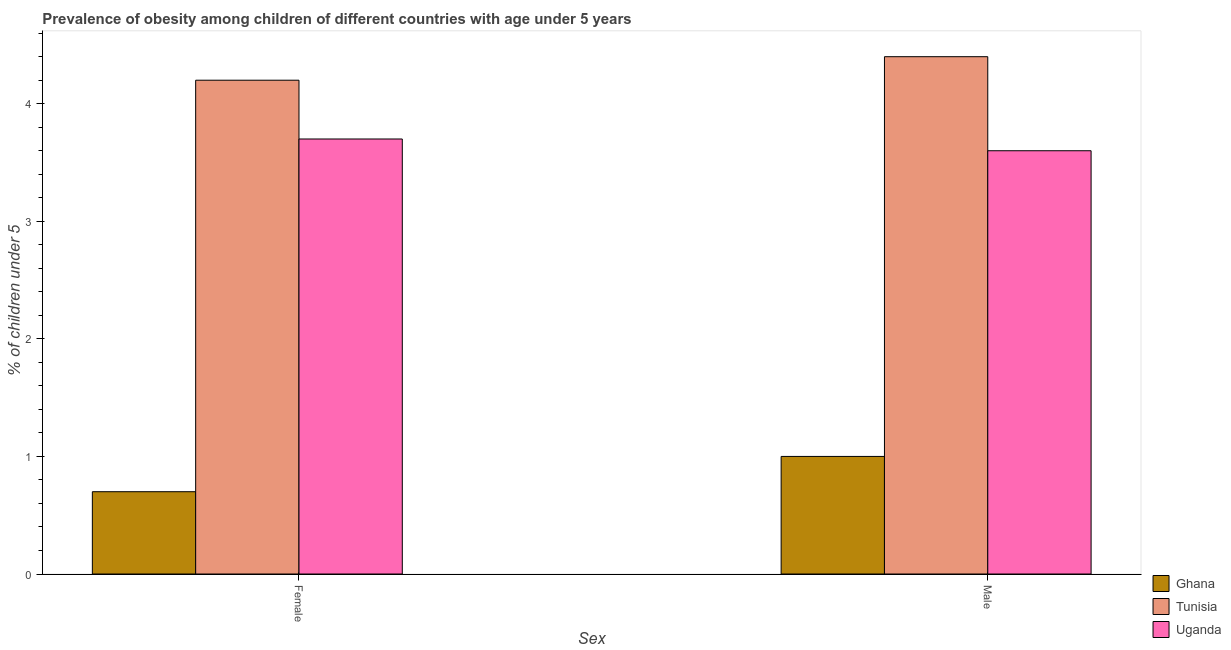How many different coloured bars are there?
Your answer should be compact. 3. How many groups of bars are there?
Your answer should be compact. 2. How many bars are there on the 1st tick from the left?
Make the answer very short. 3. What is the percentage of obese male children in Tunisia?
Make the answer very short. 4.4. Across all countries, what is the maximum percentage of obese female children?
Ensure brevity in your answer.  4.2. In which country was the percentage of obese male children maximum?
Provide a short and direct response. Tunisia. What is the total percentage of obese female children in the graph?
Give a very brief answer. 8.6. What is the difference between the percentage of obese female children in Uganda and that in Ghana?
Offer a terse response. 3. What is the difference between the percentage of obese female children in Tunisia and the percentage of obese male children in Uganda?
Give a very brief answer. 0.6. What is the difference between the percentage of obese female children and percentage of obese male children in Tunisia?
Keep it short and to the point. -0.2. What is the ratio of the percentage of obese male children in Tunisia to that in Ghana?
Provide a succinct answer. 4.4. In how many countries, is the percentage of obese male children greater than the average percentage of obese male children taken over all countries?
Offer a very short reply. 2. What does the 1st bar from the right in Male represents?
Your answer should be compact. Uganda. What is the difference between two consecutive major ticks on the Y-axis?
Your answer should be compact. 1. Are the values on the major ticks of Y-axis written in scientific E-notation?
Your answer should be very brief. No. Does the graph contain any zero values?
Your response must be concise. No. What is the title of the graph?
Your answer should be very brief. Prevalence of obesity among children of different countries with age under 5 years. What is the label or title of the X-axis?
Keep it short and to the point. Sex. What is the label or title of the Y-axis?
Ensure brevity in your answer.   % of children under 5. What is the  % of children under 5 in Ghana in Female?
Offer a terse response. 0.7. What is the  % of children under 5 in Tunisia in Female?
Provide a short and direct response. 4.2. What is the  % of children under 5 in Uganda in Female?
Your answer should be compact. 3.7. What is the  % of children under 5 of Ghana in Male?
Your answer should be very brief. 1. What is the  % of children under 5 in Tunisia in Male?
Your answer should be very brief. 4.4. What is the  % of children under 5 of Uganda in Male?
Offer a terse response. 3.6. Across all Sex, what is the maximum  % of children under 5 of Tunisia?
Your answer should be very brief. 4.4. Across all Sex, what is the maximum  % of children under 5 in Uganda?
Your answer should be very brief. 3.7. Across all Sex, what is the minimum  % of children under 5 of Ghana?
Your answer should be very brief. 0.7. Across all Sex, what is the minimum  % of children under 5 of Tunisia?
Make the answer very short. 4.2. Across all Sex, what is the minimum  % of children under 5 in Uganda?
Make the answer very short. 3.6. What is the total  % of children under 5 in Tunisia in the graph?
Your answer should be compact. 8.6. What is the difference between the  % of children under 5 of Tunisia in Female and that in Male?
Your response must be concise. -0.2. What is the difference between the  % of children under 5 of Tunisia in Female and the  % of children under 5 of Uganda in Male?
Provide a short and direct response. 0.6. What is the average  % of children under 5 of Tunisia per Sex?
Your response must be concise. 4.3. What is the average  % of children under 5 in Uganda per Sex?
Provide a short and direct response. 3.65. What is the difference between the  % of children under 5 of Ghana and  % of children under 5 of Tunisia in Female?
Offer a terse response. -3.5. What is the difference between the  % of children under 5 of Ghana and  % of children under 5 of Tunisia in Male?
Give a very brief answer. -3.4. What is the difference between the  % of children under 5 in Tunisia and  % of children under 5 in Uganda in Male?
Offer a very short reply. 0.8. What is the ratio of the  % of children under 5 in Tunisia in Female to that in Male?
Keep it short and to the point. 0.95. What is the ratio of the  % of children under 5 of Uganda in Female to that in Male?
Provide a succinct answer. 1.03. What is the difference between the highest and the second highest  % of children under 5 of Ghana?
Make the answer very short. 0.3. What is the difference between the highest and the second highest  % of children under 5 of Tunisia?
Provide a short and direct response. 0.2. What is the difference between the highest and the lowest  % of children under 5 in Tunisia?
Provide a short and direct response. 0.2. What is the difference between the highest and the lowest  % of children under 5 of Uganda?
Your answer should be compact. 0.1. 